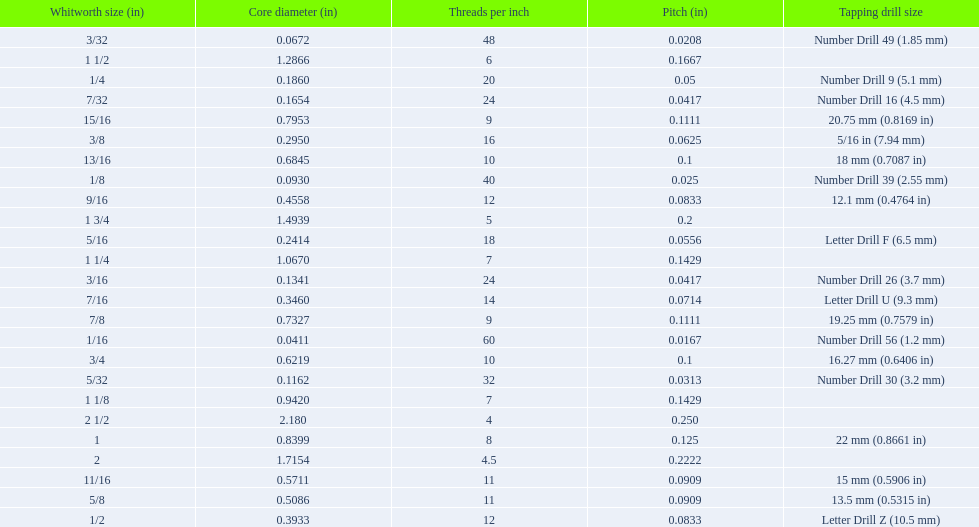What was the core diameter of a number drill 26 0.1341. What is this measurement in whitworth size? 3/16. 